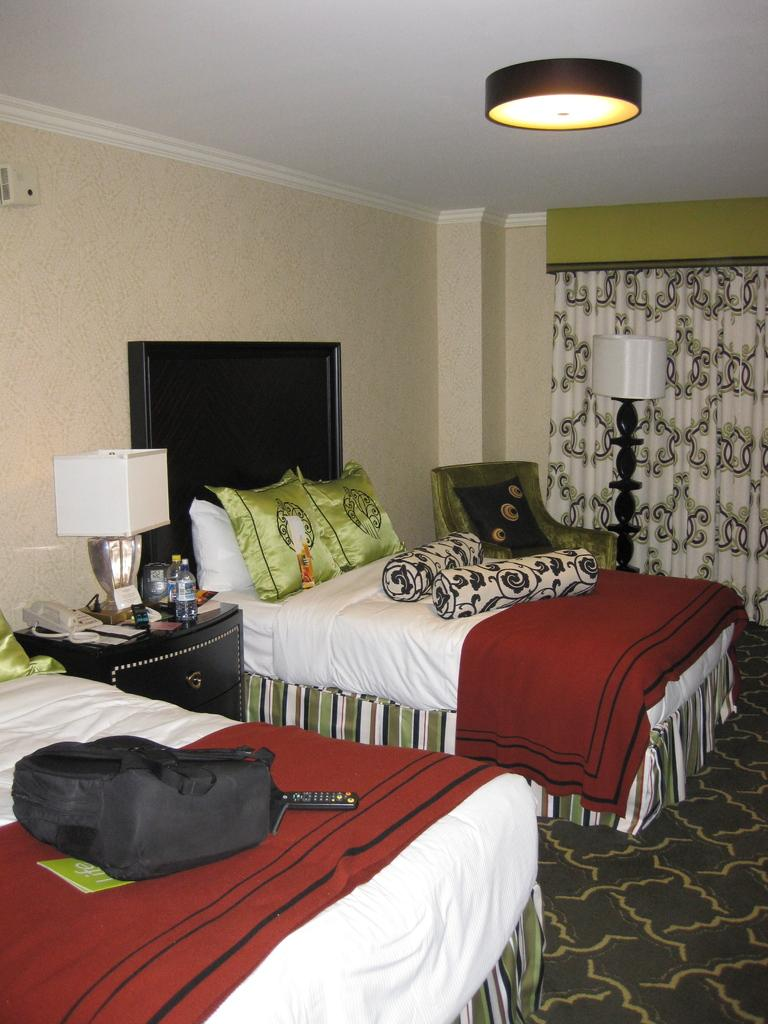What type of furniture is present in the image? There are beds in the image. What can be found on the beds? There are pillows on the bed. What additional item is on the bed? There is a backpack on the bed. What type of lighting is present in the image? There is a lamp and a roof light in the image. What type of plate is used to serve dinner in the image? There is no plate present in the image. What season is depicted in the image? The image does not depict a specific season, as there are no seasonal cues provided. 